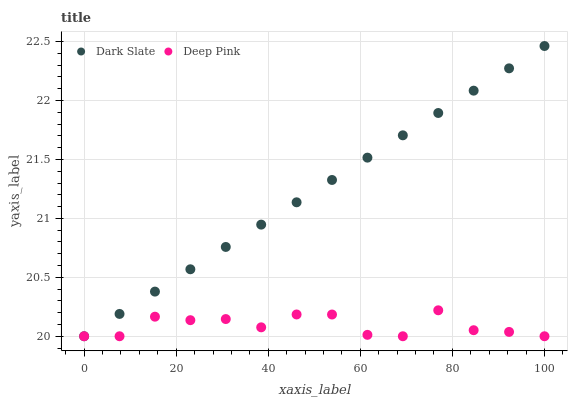Does Deep Pink have the minimum area under the curve?
Answer yes or no. Yes. Does Dark Slate have the maximum area under the curve?
Answer yes or no. Yes. Does Deep Pink have the maximum area under the curve?
Answer yes or no. No. Is Dark Slate the smoothest?
Answer yes or no. Yes. Is Deep Pink the roughest?
Answer yes or no. Yes. Is Deep Pink the smoothest?
Answer yes or no. No. Does Dark Slate have the lowest value?
Answer yes or no. Yes. Does Dark Slate have the highest value?
Answer yes or no. Yes. Does Deep Pink have the highest value?
Answer yes or no. No. Does Dark Slate intersect Deep Pink?
Answer yes or no. Yes. Is Dark Slate less than Deep Pink?
Answer yes or no. No. Is Dark Slate greater than Deep Pink?
Answer yes or no. No. 